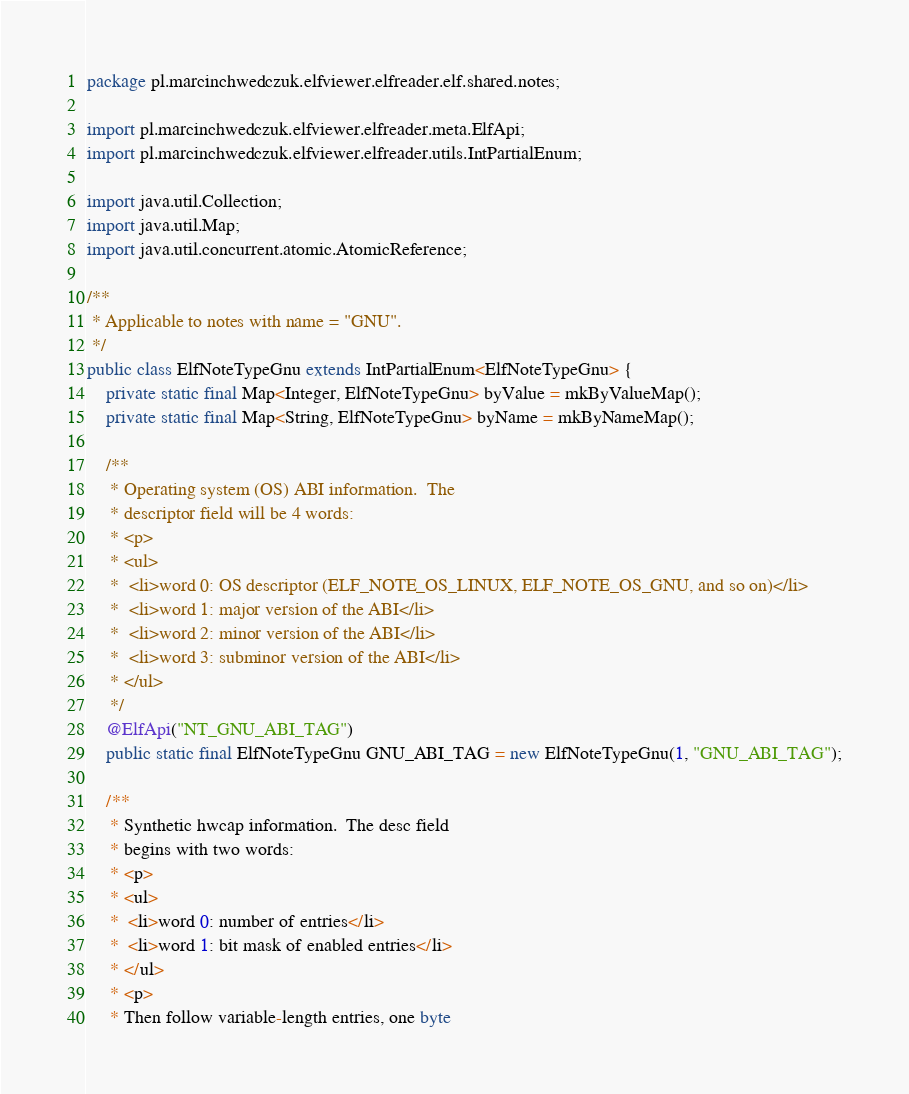<code> <loc_0><loc_0><loc_500><loc_500><_Java_>package pl.marcinchwedczuk.elfviewer.elfreader.elf.shared.notes;

import pl.marcinchwedczuk.elfviewer.elfreader.meta.ElfApi;
import pl.marcinchwedczuk.elfviewer.elfreader.utils.IntPartialEnum;

import java.util.Collection;
import java.util.Map;
import java.util.concurrent.atomic.AtomicReference;

/**
 * Applicable to notes with name = "GNU".
 */
public class ElfNoteTypeGnu extends IntPartialEnum<ElfNoteTypeGnu> {
    private static final Map<Integer, ElfNoteTypeGnu> byValue = mkByValueMap();
    private static final Map<String, ElfNoteTypeGnu> byName = mkByNameMap();

    /**
     * Operating system (OS) ABI information.  The
     * descriptor field will be 4 words:
     * <p>
     * <ul>
     *  <li>word 0: OS descriptor (ELF_NOTE_OS_LINUX, ELF_NOTE_OS_GNU, and so on)</li>
     *  <li>word 1: major version of the ABI</li>
     *  <li>word 2: minor version of the ABI</li>
     *  <li>word 3: subminor version of the ABI</li>
     * </ul>
     */
    @ElfApi("NT_GNU_ABI_TAG")
    public static final ElfNoteTypeGnu GNU_ABI_TAG = new ElfNoteTypeGnu(1, "GNU_ABI_TAG");

    /**
     * Synthetic hwcap information.  The desc field
     * begins with two words:
     * <p>
     * <ul>
     *  <li>word 0: number of entries</li>
     *  <li>word 1: bit mask of enabled entries</li>
     * </ul>
     * <p>
     * Then follow variable-length entries, one byte</code> 